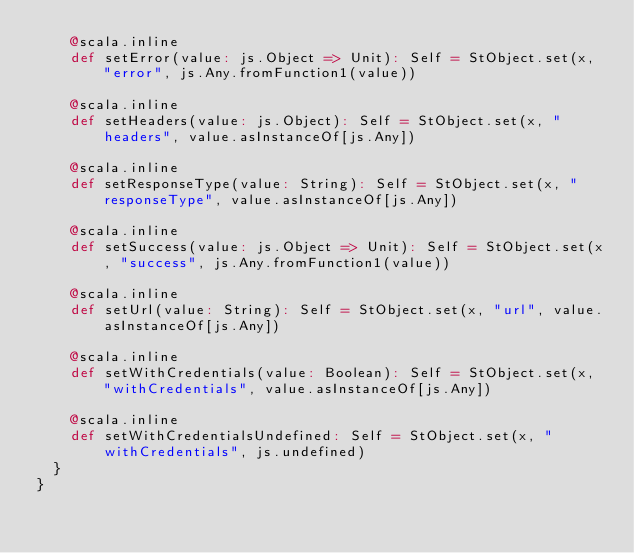Convert code to text. <code><loc_0><loc_0><loc_500><loc_500><_Scala_>    @scala.inline
    def setError(value: js.Object => Unit): Self = StObject.set(x, "error", js.Any.fromFunction1(value))
    
    @scala.inline
    def setHeaders(value: js.Object): Self = StObject.set(x, "headers", value.asInstanceOf[js.Any])
    
    @scala.inline
    def setResponseType(value: String): Self = StObject.set(x, "responseType", value.asInstanceOf[js.Any])
    
    @scala.inline
    def setSuccess(value: js.Object => Unit): Self = StObject.set(x, "success", js.Any.fromFunction1(value))
    
    @scala.inline
    def setUrl(value: String): Self = StObject.set(x, "url", value.asInstanceOf[js.Any])
    
    @scala.inline
    def setWithCredentials(value: Boolean): Self = StObject.set(x, "withCredentials", value.asInstanceOf[js.Any])
    
    @scala.inline
    def setWithCredentialsUndefined: Self = StObject.set(x, "withCredentials", js.undefined)
  }
}
</code> 